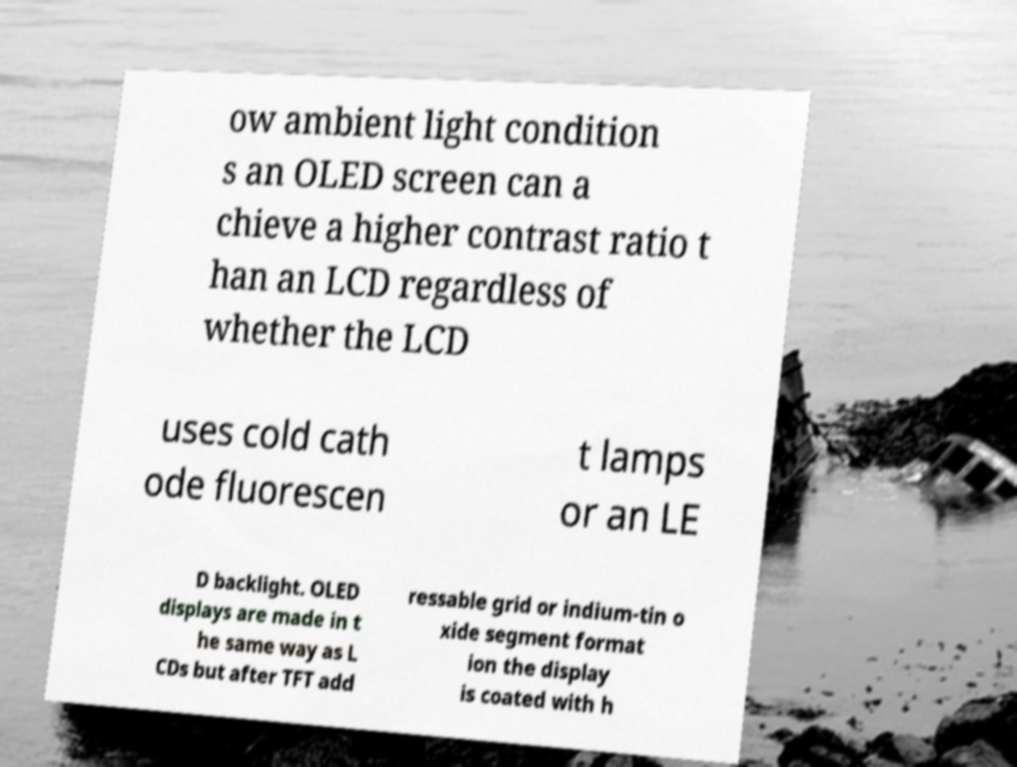I need the written content from this picture converted into text. Can you do that? ow ambient light condition s an OLED screen can a chieve a higher contrast ratio t han an LCD regardless of whether the LCD uses cold cath ode fluorescen t lamps or an LE D backlight. OLED displays are made in t he same way as L CDs but after TFT add ressable grid or indium-tin o xide segment format ion the display is coated with h 